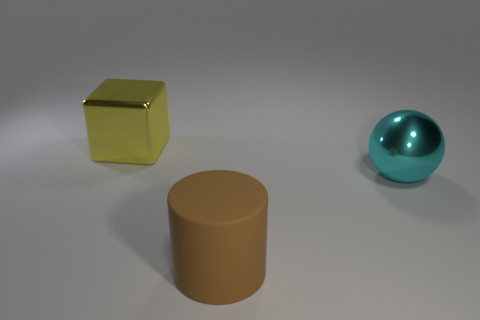How many objects are large shiny objects or small cyan objects?
Offer a very short reply. 2. There is a object that is in front of the cyan shiny ball; does it have the same shape as the metal object behind the ball?
Ensure brevity in your answer.  No. The thing that is in front of the ball has what shape?
Provide a succinct answer. Cylinder. Is the number of brown cylinders that are on the left side of the big brown rubber cylinder the same as the number of large brown things to the right of the yellow metal object?
Offer a very short reply. No. What number of objects are either big objects or things that are in front of the yellow object?
Ensure brevity in your answer.  3. There is a big thing that is both on the left side of the cyan object and to the right of the block; what shape is it?
Keep it short and to the point. Cylinder. What material is the large thing in front of the big metal object in front of the yellow block?
Provide a succinct answer. Rubber. Do the large object on the right side of the brown matte object and the big brown object have the same material?
Provide a short and direct response. No. What is the size of the metallic object that is to the right of the yellow shiny object?
Your answer should be compact. Large. There is a object in front of the big cyan ball; is there a large cyan metallic ball on the right side of it?
Your answer should be very brief. Yes. 